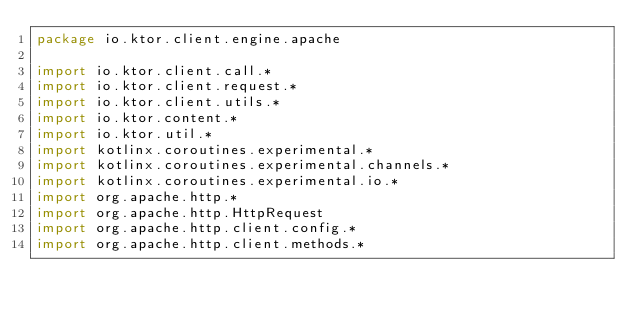Convert code to text. <code><loc_0><loc_0><loc_500><loc_500><_Kotlin_>package io.ktor.client.engine.apache

import io.ktor.client.call.*
import io.ktor.client.request.*
import io.ktor.client.utils.*
import io.ktor.content.*
import io.ktor.util.*
import kotlinx.coroutines.experimental.*
import kotlinx.coroutines.experimental.channels.*
import kotlinx.coroutines.experimental.io.*
import org.apache.http.*
import org.apache.http.HttpRequest
import org.apache.http.client.config.*
import org.apache.http.client.methods.*</code> 